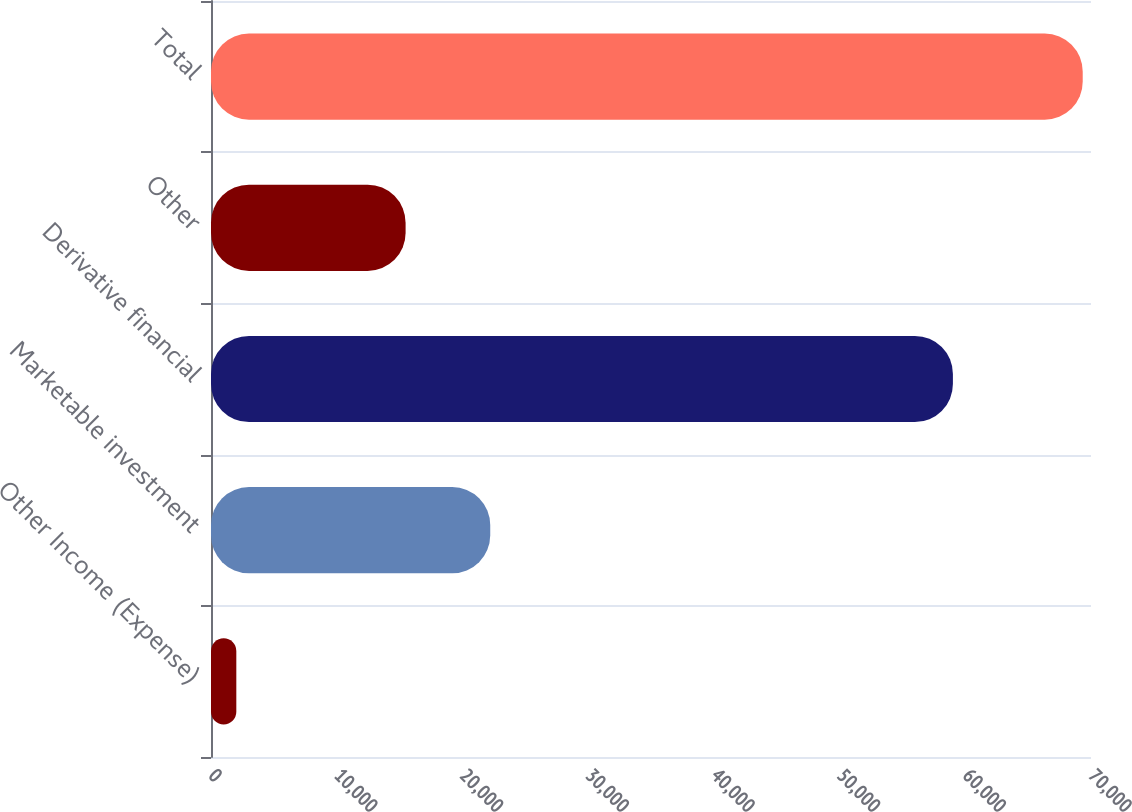Convert chart. <chart><loc_0><loc_0><loc_500><loc_500><bar_chart><fcel>Other Income (Expense)<fcel>Marketable investment<fcel>Derivative financial<fcel>Other<fcel>Total<nl><fcel>2014<fcel>22212.1<fcel>59015<fcel>15479.4<fcel>69341<nl></chart> 